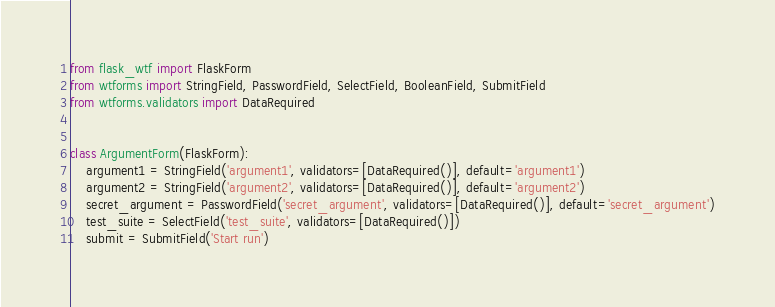Convert code to text. <code><loc_0><loc_0><loc_500><loc_500><_Python_>from flask_wtf import FlaskForm
from wtforms import StringField, PasswordField, SelectField, BooleanField, SubmitField
from wtforms.validators import DataRequired


class ArgumentForm(FlaskForm):
    argument1 = StringField('argument1', validators=[DataRequired()], default='argument1')
    argument2 = StringField('argument2', validators=[DataRequired()], default='argument2')
    secret_argument = PasswordField('secret_argument', validators=[DataRequired()], default='secret_argument')
    test_suite = SelectField('test_suite', validators=[DataRequired()])
    submit = SubmitField('Start run')

</code> 